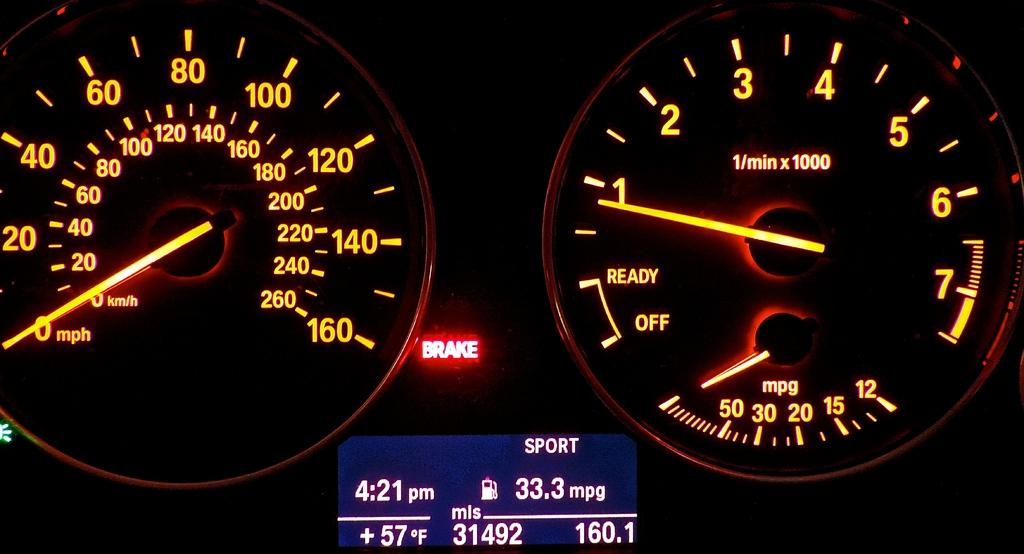<image>
Create a compact narrative representing the image presented. Car Speedometer and RPM that has the Emergency Brake on, and says Sport 4:21 PM, 33 MPG. 